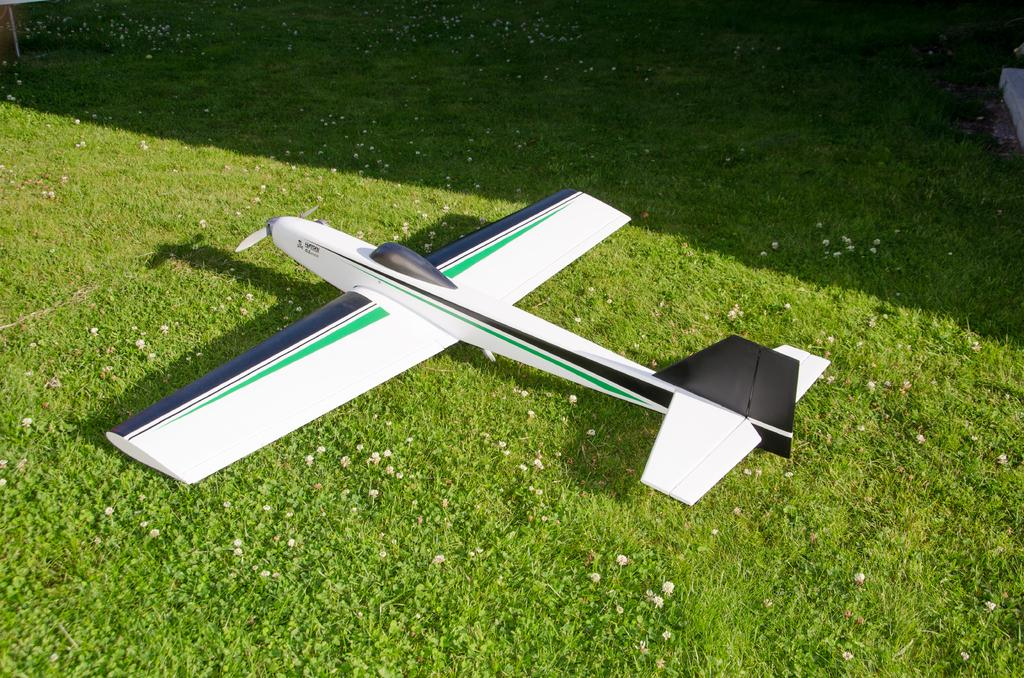What type of toy is on the ground in the image? There is a toy aircraft on the ground. What type of terrain is visible in the image? There is grass on the ground in the image. What other small plants can be seen on the ground? There are small flowers on the ground. What type of humor can be seen on the wall in the image? There is no wall or humor present in the image; it features a toy aircraft on the ground with grass and small flowers. 